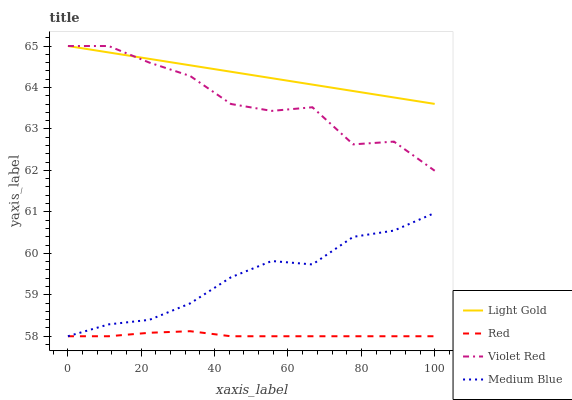Does Red have the minimum area under the curve?
Answer yes or no. Yes. Does Light Gold have the maximum area under the curve?
Answer yes or no. Yes. Does Violet Red have the minimum area under the curve?
Answer yes or no. No. Does Violet Red have the maximum area under the curve?
Answer yes or no. No. Is Light Gold the smoothest?
Answer yes or no. Yes. Is Violet Red the roughest?
Answer yes or no. Yes. Is Violet Red the smoothest?
Answer yes or no. No. Is Light Gold the roughest?
Answer yes or no. No. Does Violet Red have the lowest value?
Answer yes or no. No. Does Red have the highest value?
Answer yes or no. No. Is Medium Blue less than Violet Red?
Answer yes or no. Yes. Is Light Gold greater than Medium Blue?
Answer yes or no. Yes. Does Medium Blue intersect Violet Red?
Answer yes or no. No. 